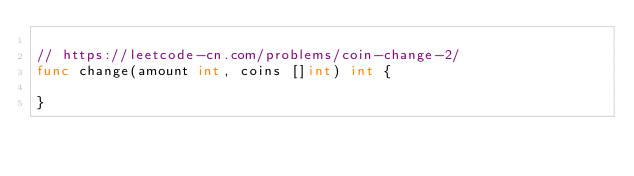<code> <loc_0><loc_0><loc_500><loc_500><_Go_>
// https://leetcode-cn.com/problems/coin-change-2/
func change(amount int, coins []int) int {

}</code> 